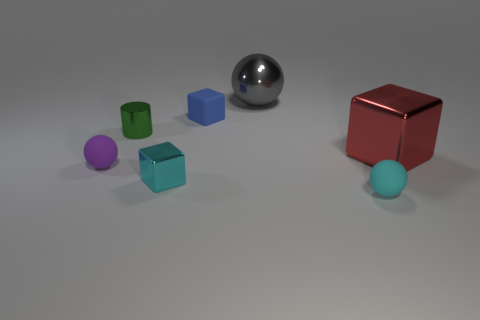Add 2 matte objects. How many objects exist? 9 Subtract all cubes. How many objects are left? 4 Add 6 red shiny objects. How many red shiny objects exist? 7 Subtract 1 red blocks. How many objects are left? 6 Subtract all tiny blue blocks. Subtract all blue matte objects. How many objects are left? 5 Add 2 blue matte objects. How many blue matte objects are left? 3 